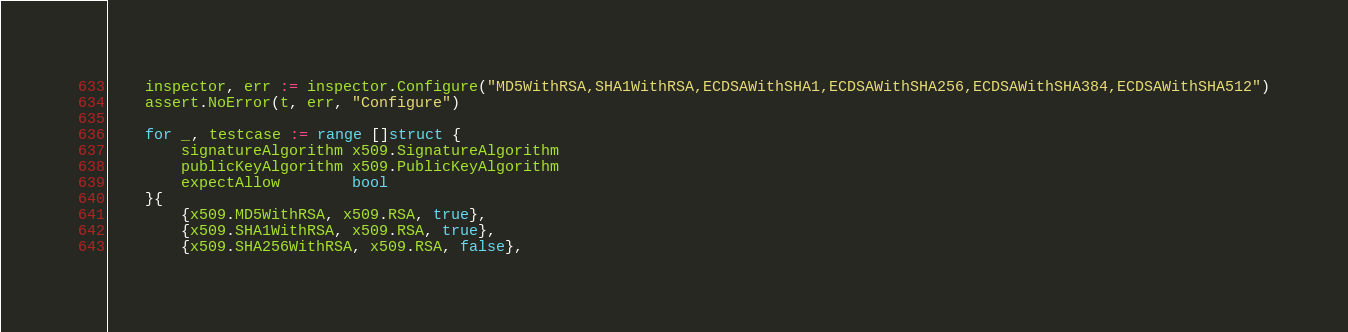Convert code to text. <code><loc_0><loc_0><loc_500><loc_500><_Go_>
	inspector, err := inspector.Configure("MD5WithRSA,SHA1WithRSA,ECDSAWithSHA1,ECDSAWithSHA256,ECDSAWithSHA384,ECDSAWithSHA512")
	assert.NoError(t, err, "Configure")

	for _, testcase := range []struct {
		signatureAlgorithm x509.SignatureAlgorithm
		publicKeyAlgorithm x509.PublicKeyAlgorithm
		expectAllow        bool
	}{
		{x509.MD5WithRSA, x509.RSA, true},
		{x509.SHA1WithRSA, x509.RSA, true},
		{x509.SHA256WithRSA, x509.RSA, false},</code> 